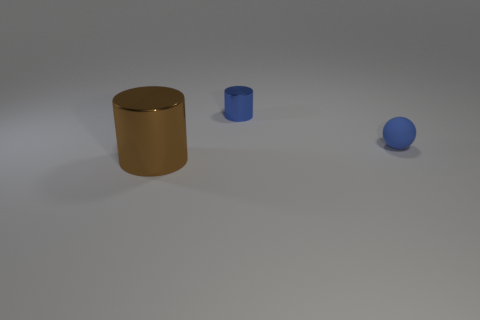Add 2 small spheres. How many objects exist? 5 Subtract all balls. How many objects are left? 2 Subtract 1 blue cylinders. How many objects are left? 2 Subtract all purple metal blocks. Subtract all blue rubber balls. How many objects are left? 2 Add 3 big things. How many big things are left? 4 Add 2 small blue matte objects. How many small blue matte objects exist? 3 